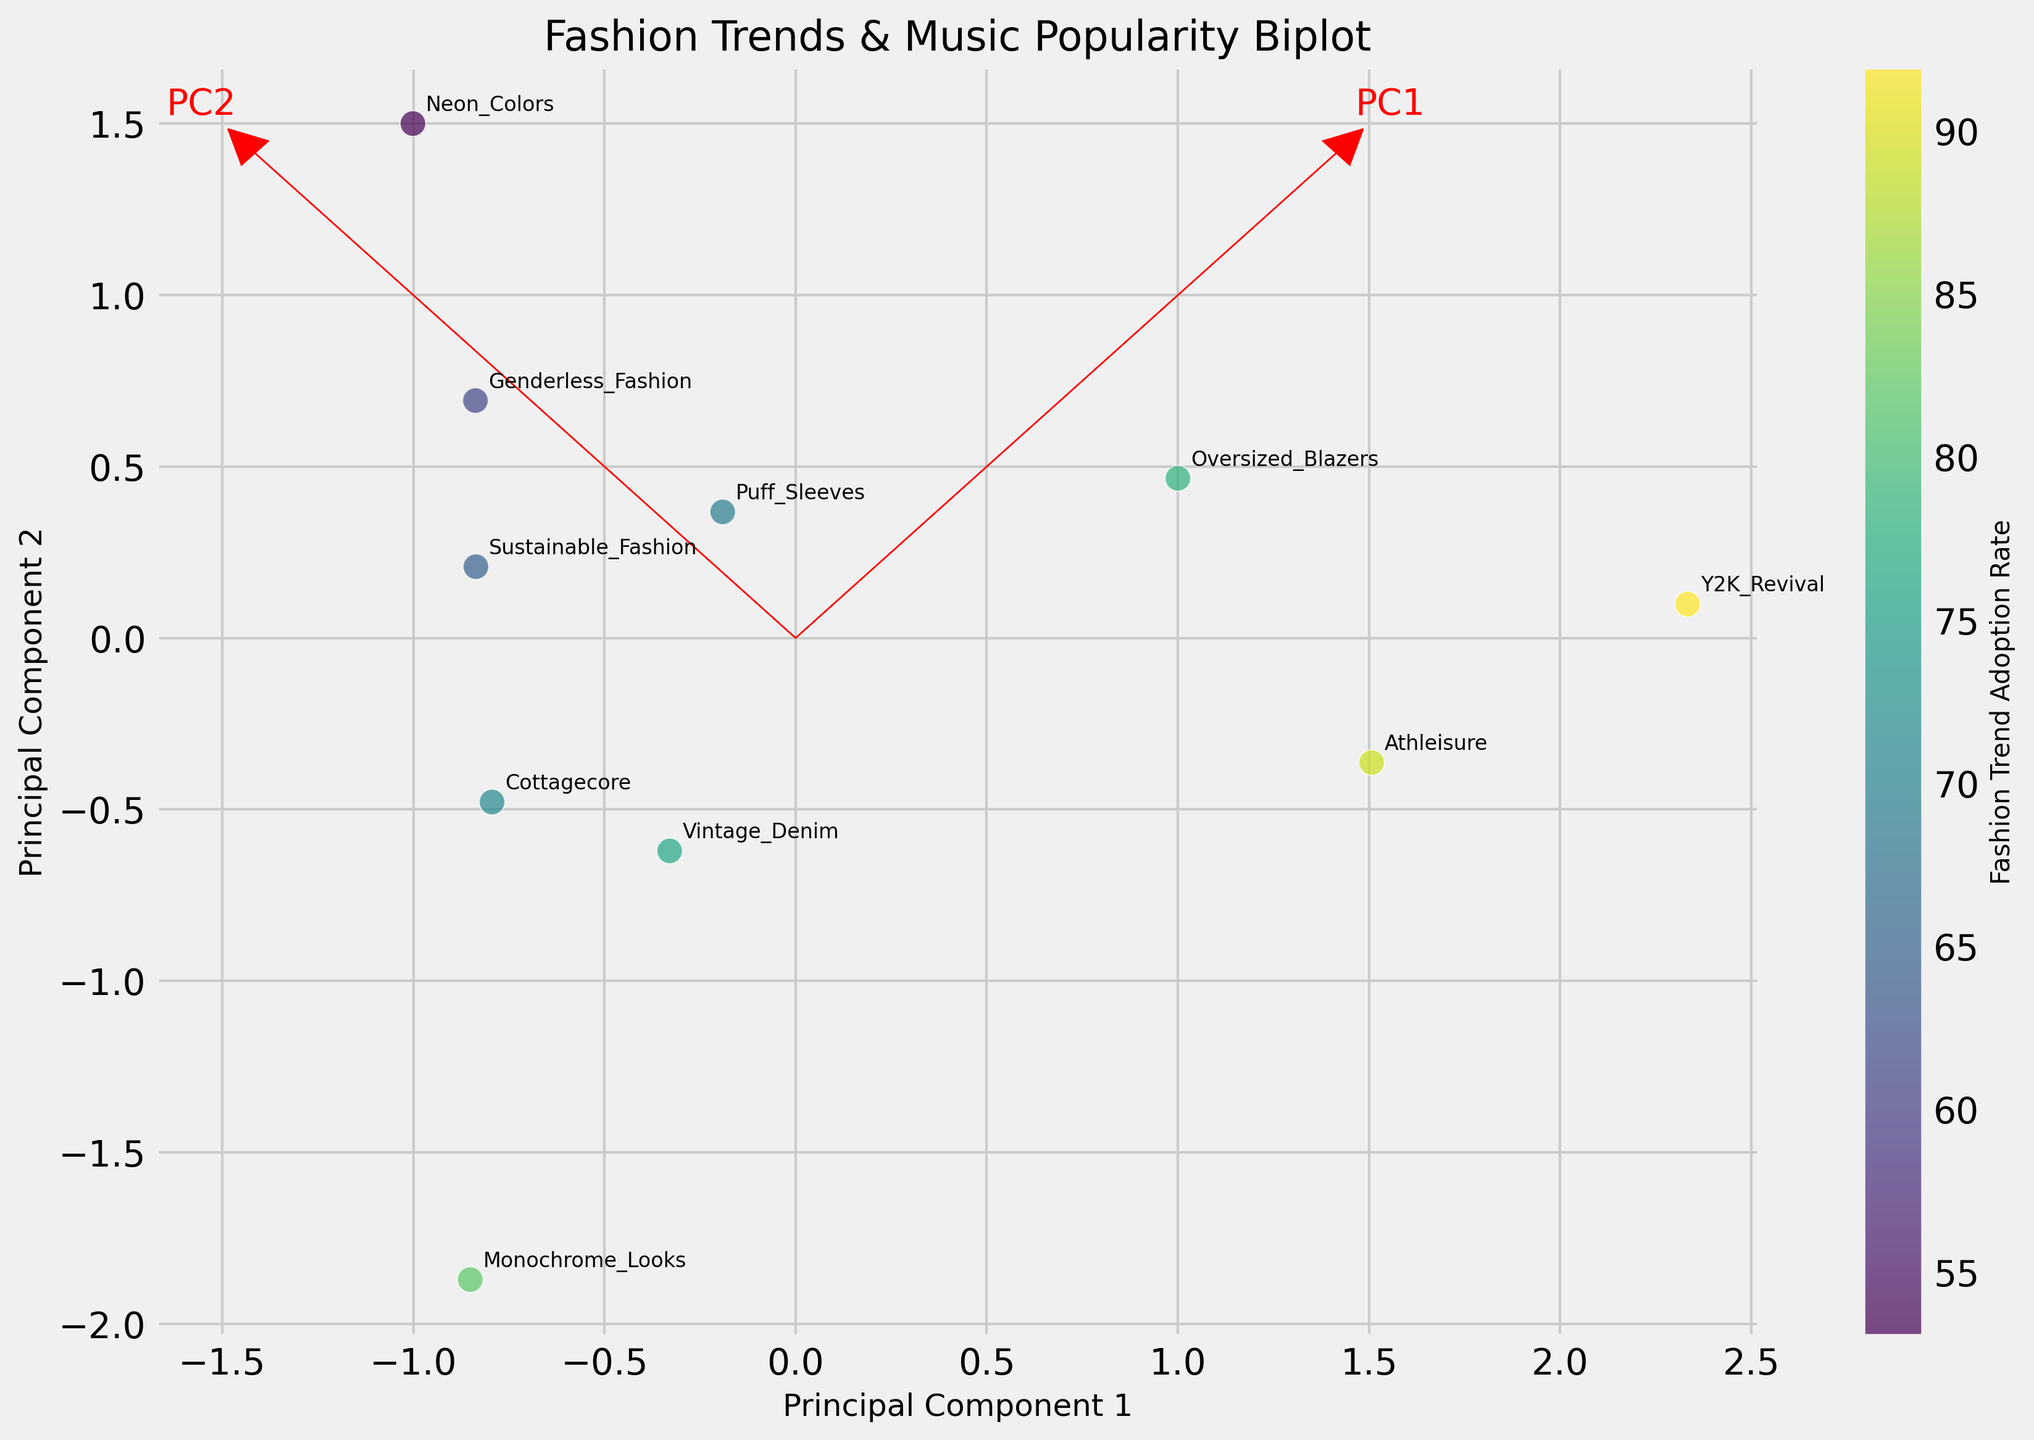What is the title of the plot? The title of the plot is usually found at the top of the figure. In this case, it is set in a larger font size for easy visibility.
Answer: Fashion Trends & Music Popularity Biplot How many fashion trends are represented in the plot? Each data point corresponds to a fashion trend, and there is typically one annotation for each data point. By counting the annotations, we can determine the number of fashion trends.
Answer: 10 Which fashion trend has the highest adoption rate? The adoption rates are color-coded with a corresponding color bar. By identifying the darkest point (representing the highest value) and its label, we can find the trend with the highest adoption rate.
Answer: Y2K Revival Are there any fashion trends with a lower adoption rate but higher music popularity scores? By comparing the positions of the data points and their associated values on the x-axis (adoption rate) and y-axis (popularity score), we can determine if such trends exist. For detailed interpretation, look for points to the left on the x-axis (low adoption) but higher on y-axis (high popularity).
Answer: Neon Colors and Puff Sleeves Which principal component explains more variability in the data? The principal component with the higher eigenvalue explains more variability. The direction and length of the eigenvector arrows in the plot can also hint at this, but it requires counting or knowing the eigenvalue.
Answer: Principal Component 1 Which music genres are associated with the trends having the highest and lowest adoption rates? By identifying the trends with the highest and lowest adoption rates and then checking their associated music genres, we can answer this. High adoption rate: Y2K Revival with Pop. Low adoption rate: Neon Colors with EDM.
Answer: Pop and EDM How do Monochrome Looks and Cottagecore compare in terms of adoption rate and popularity score? By locating both points on the plot, we can visually compare their distances on the x-axis (adoption rate) and y-axis (popularity score).
Answer: Monochrome Looks has a higher adoption rate and lower popularity score compared to Cottagecore What does the color gradient in the plot represent? Color gradients typically represent a variable, often explained by a color bar. Here, the gradient represents the adoption rate of fashion trends.
Answer: Fashion Trend Adoption Rate What are the coordinates of the trend “Athleisure” in the principal component space? Locate the annotated point for "Athleisure" on the plot and read its coordinates on the Principal Component 1 and Principal Component 2 axes.
Answer: (approximately 1.5, -0.5) Does the plot indicate a positive correlation between fashion adoption rates and music popularity scores? By observing the general trend of the data points in the biplot, we can infer if there's a positive correlation. If points trend from lower-left to upper-right, a positive correlation exists.
Answer: Yes 